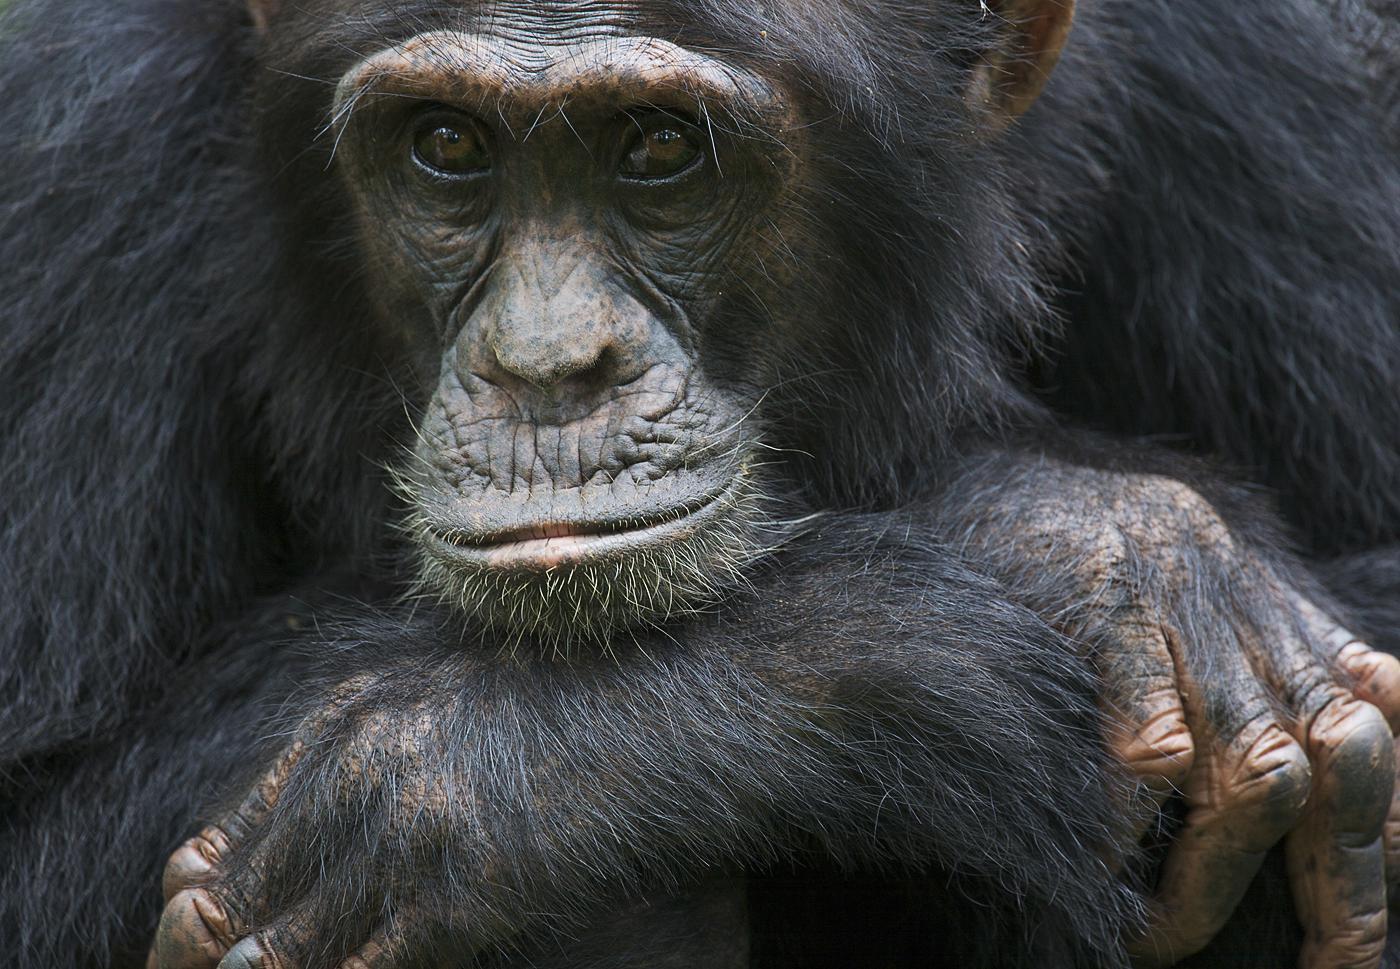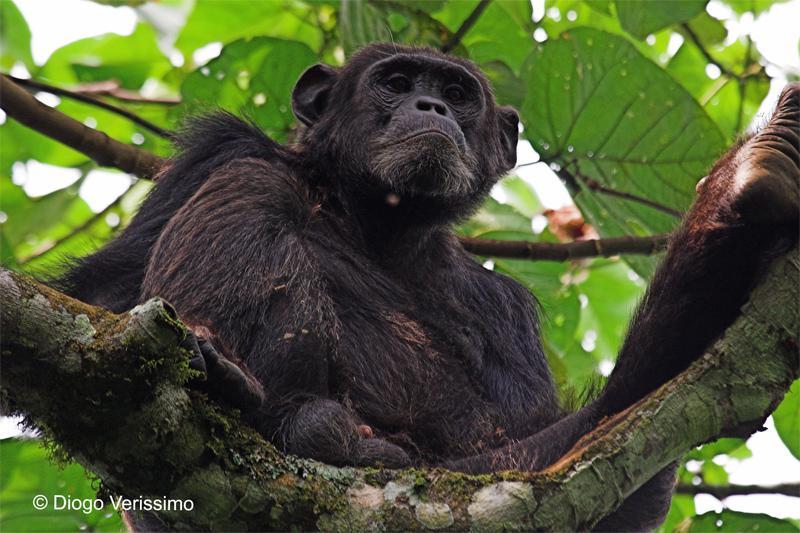The first image is the image on the left, the second image is the image on the right. For the images displayed, is the sentence "The right image shows a chimp looking down over a curved branch from a treetop vantage point." factually correct? Answer yes or no. Yes. The first image is the image on the left, the second image is the image on the right. Analyze the images presented: Is the assertion "The primate in the image on the right is sitting on a tree branch." valid? Answer yes or no. Yes. 